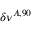<formula> <loc_0><loc_0><loc_500><loc_500>\delta \nu ^ { A , 9 0 }</formula> 